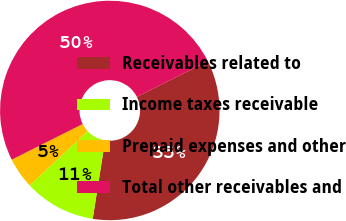Convert chart. <chart><loc_0><loc_0><loc_500><loc_500><pie_chart><fcel>Receivables related to<fcel>Income taxes receivable<fcel>Prepaid expenses and other<fcel>Total other receivables and<nl><fcel>34.88%<fcel>10.55%<fcel>4.56%<fcel>50.0%<nl></chart> 